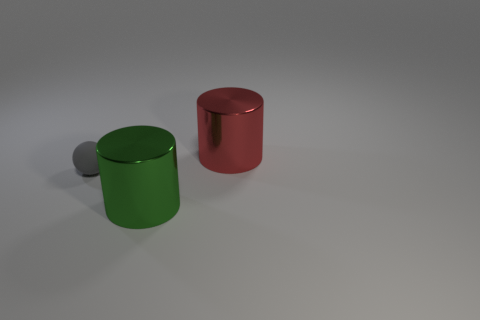How many other gray balls have the same material as the tiny gray ball?
Make the answer very short. 0. Is the size of the shiny cylinder in front of the small rubber object the same as the red metallic thing that is to the right of the sphere?
Ensure brevity in your answer.  Yes. What is the color of the large metal cylinder that is in front of the large object behind the cylinder in front of the large red metal object?
Make the answer very short. Green. Is there a tiny brown thing of the same shape as the red metallic thing?
Offer a very short reply. No. Is the number of tiny gray balls that are behind the large red thing the same as the number of tiny things behind the big green metallic thing?
Offer a very short reply. No. Does the large object on the left side of the large red metallic cylinder have the same shape as the matte thing?
Keep it short and to the point. No. Is the gray rubber thing the same shape as the green object?
Your response must be concise. No. How many shiny objects are either small spheres or big cylinders?
Provide a succinct answer. 2. Does the red object have the same size as the gray object?
Give a very brief answer. No. What number of things are cyan rubber objects or red metallic cylinders right of the small gray matte thing?
Provide a short and direct response. 1. 